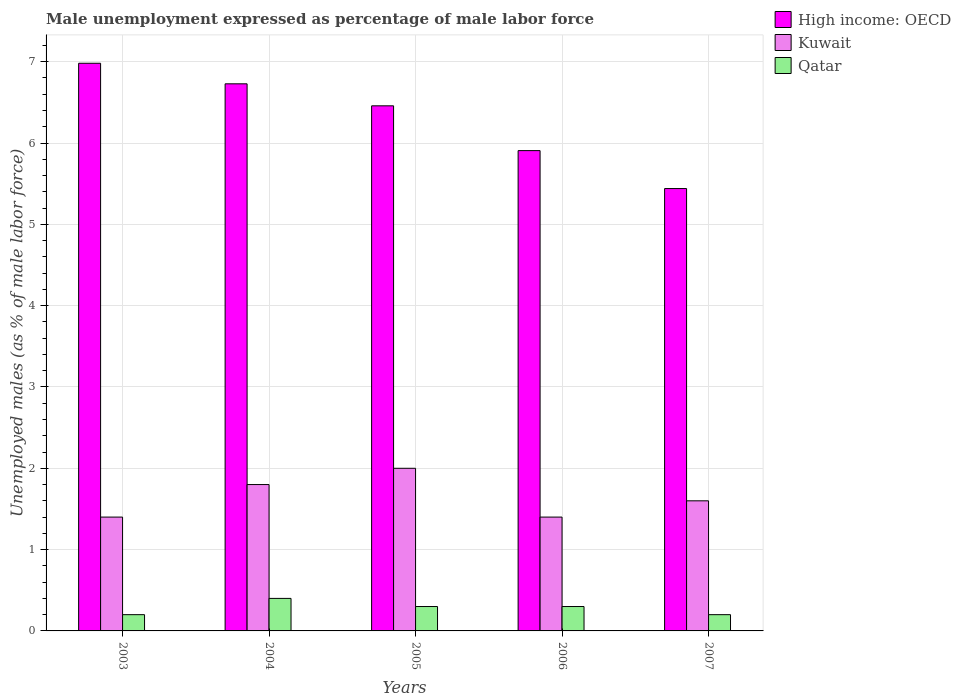How many groups of bars are there?
Offer a very short reply. 5. Are the number of bars on each tick of the X-axis equal?
Keep it short and to the point. Yes. How many bars are there on the 5th tick from the right?
Provide a succinct answer. 3. What is the label of the 1st group of bars from the left?
Keep it short and to the point. 2003. In how many cases, is the number of bars for a given year not equal to the number of legend labels?
Make the answer very short. 0. What is the unemployment in males in in Kuwait in 2007?
Make the answer very short. 1.6. Across all years, what is the maximum unemployment in males in in Kuwait?
Ensure brevity in your answer.  2. Across all years, what is the minimum unemployment in males in in High income: OECD?
Make the answer very short. 5.44. In which year was the unemployment in males in in Kuwait minimum?
Keep it short and to the point. 2003. What is the total unemployment in males in in Qatar in the graph?
Give a very brief answer. 1.4. What is the difference between the unemployment in males in in Qatar in 2003 and that in 2004?
Offer a terse response. -0.2. What is the difference between the unemployment in males in in Qatar in 2003 and the unemployment in males in in Kuwait in 2004?
Provide a short and direct response. -1.6. What is the average unemployment in males in in Kuwait per year?
Make the answer very short. 1.64. In the year 2004, what is the difference between the unemployment in males in in Kuwait and unemployment in males in in High income: OECD?
Offer a terse response. -4.93. What is the ratio of the unemployment in males in in High income: OECD in 2004 to that in 2005?
Provide a succinct answer. 1.04. Is the unemployment in males in in High income: OECD in 2004 less than that in 2005?
Your response must be concise. No. Is the difference between the unemployment in males in in Kuwait in 2003 and 2005 greater than the difference between the unemployment in males in in High income: OECD in 2003 and 2005?
Provide a short and direct response. No. What is the difference between the highest and the second highest unemployment in males in in Kuwait?
Ensure brevity in your answer.  0.2. What is the difference between the highest and the lowest unemployment in males in in Kuwait?
Offer a terse response. 0.6. In how many years, is the unemployment in males in in Qatar greater than the average unemployment in males in in Qatar taken over all years?
Give a very brief answer. 3. Is the sum of the unemployment in males in in Qatar in 2004 and 2005 greater than the maximum unemployment in males in in High income: OECD across all years?
Your answer should be compact. No. What does the 3rd bar from the left in 2004 represents?
Your response must be concise. Qatar. What does the 1st bar from the right in 2007 represents?
Give a very brief answer. Qatar. Are all the bars in the graph horizontal?
Offer a terse response. No. Does the graph contain any zero values?
Provide a succinct answer. No. How are the legend labels stacked?
Offer a very short reply. Vertical. What is the title of the graph?
Your answer should be very brief. Male unemployment expressed as percentage of male labor force. What is the label or title of the X-axis?
Keep it short and to the point. Years. What is the label or title of the Y-axis?
Ensure brevity in your answer.  Unemployed males (as % of male labor force). What is the Unemployed males (as % of male labor force) in High income: OECD in 2003?
Offer a very short reply. 6.98. What is the Unemployed males (as % of male labor force) in Kuwait in 2003?
Your answer should be very brief. 1.4. What is the Unemployed males (as % of male labor force) of Qatar in 2003?
Give a very brief answer. 0.2. What is the Unemployed males (as % of male labor force) of High income: OECD in 2004?
Your response must be concise. 6.73. What is the Unemployed males (as % of male labor force) of Kuwait in 2004?
Your answer should be compact. 1.8. What is the Unemployed males (as % of male labor force) of Qatar in 2004?
Ensure brevity in your answer.  0.4. What is the Unemployed males (as % of male labor force) in High income: OECD in 2005?
Provide a short and direct response. 6.46. What is the Unemployed males (as % of male labor force) of Qatar in 2005?
Ensure brevity in your answer.  0.3. What is the Unemployed males (as % of male labor force) in High income: OECD in 2006?
Offer a very short reply. 5.91. What is the Unemployed males (as % of male labor force) in Kuwait in 2006?
Ensure brevity in your answer.  1.4. What is the Unemployed males (as % of male labor force) of Qatar in 2006?
Your response must be concise. 0.3. What is the Unemployed males (as % of male labor force) of High income: OECD in 2007?
Offer a very short reply. 5.44. What is the Unemployed males (as % of male labor force) of Kuwait in 2007?
Make the answer very short. 1.6. What is the Unemployed males (as % of male labor force) in Qatar in 2007?
Your answer should be very brief. 0.2. Across all years, what is the maximum Unemployed males (as % of male labor force) in High income: OECD?
Your answer should be very brief. 6.98. Across all years, what is the maximum Unemployed males (as % of male labor force) in Kuwait?
Offer a terse response. 2. Across all years, what is the maximum Unemployed males (as % of male labor force) of Qatar?
Give a very brief answer. 0.4. Across all years, what is the minimum Unemployed males (as % of male labor force) in High income: OECD?
Your answer should be compact. 5.44. Across all years, what is the minimum Unemployed males (as % of male labor force) of Kuwait?
Offer a terse response. 1.4. Across all years, what is the minimum Unemployed males (as % of male labor force) in Qatar?
Provide a short and direct response. 0.2. What is the total Unemployed males (as % of male labor force) in High income: OECD in the graph?
Your answer should be compact. 31.51. What is the total Unemployed males (as % of male labor force) of Qatar in the graph?
Offer a very short reply. 1.4. What is the difference between the Unemployed males (as % of male labor force) of High income: OECD in 2003 and that in 2004?
Ensure brevity in your answer.  0.25. What is the difference between the Unemployed males (as % of male labor force) of Kuwait in 2003 and that in 2004?
Give a very brief answer. -0.4. What is the difference between the Unemployed males (as % of male labor force) in High income: OECD in 2003 and that in 2005?
Your answer should be very brief. 0.52. What is the difference between the Unemployed males (as % of male labor force) of High income: OECD in 2003 and that in 2006?
Make the answer very short. 1.07. What is the difference between the Unemployed males (as % of male labor force) in Kuwait in 2003 and that in 2006?
Your response must be concise. 0. What is the difference between the Unemployed males (as % of male labor force) of High income: OECD in 2003 and that in 2007?
Make the answer very short. 1.54. What is the difference between the Unemployed males (as % of male labor force) of Kuwait in 2003 and that in 2007?
Your response must be concise. -0.2. What is the difference between the Unemployed males (as % of male labor force) of Qatar in 2003 and that in 2007?
Offer a very short reply. 0. What is the difference between the Unemployed males (as % of male labor force) in High income: OECD in 2004 and that in 2005?
Offer a terse response. 0.27. What is the difference between the Unemployed males (as % of male labor force) of Kuwait in 2004 and that in 2005?
Your response must be concise. -0.2. What is the difference between the Unemployed males (as % of male labor force) of High income: OECD in 2004 and that in 2006?
Keep it short and to the point. 0.82. What is the difference between the Unemployed males (as % of male labor force) of Kuwait in 2004 and that in 2006?
Ensure brevity in your answer.  0.4. What is the difference between the Unemployed males (as % of male labor force) of Qatar in 2004 and that in 2006?
Ensure brevity in your answer.  0.1. What is the difference between the Unemployed males (as % of male labor force) of High income: OECD in 2004 and that in 2007?
Give a very brief answer. 1.29. What is the difference between the Unemployed males (as % of male labor force) in Kuwait in 2004 and that in 2007?
Your answer should be compact. 0.2. What is the difference between the Unemployed males (as % of male labor force) in High income: OECD in 2005 and that in 2006?
Keep it short and to the point. 0.55. What is the difference between the Unemployed males (as % of male labor force) in High income: OECD in 2005 and that in 2007?
Provide a succinct answer. 1.02. What is the difference between the Unemployed males (as % of male labor force) of Kuwait in 2005 and that in 2007?
Your answer should be compact. 0.4. What is the difference between the Unemployed males (as % of male labor force) of Qatar in 2005 and that in 2007?
Give a very brief answer. 0.1. What is the difference between the Unemployed males (as % of male labor force) of High income: OECD in 2006 and that in 2007?
Give a very brief answer. 0.47. What is the difference between the Unemployed males (as % of male labor force) of Qatar in 2006 and that in 2007?
Keep it short and to the point. 0.1. What is the difference between the Unemployed males (as % of male labor force) of High income: OECD in 2003 and the Unemployed males (as % of male labor force) of Kuwait in 2004?
Your answer should be very brief. 5.18. What is the difference between the Unemployed males (as % of male labor force) in High income: OECD in 2003 and the Unemployed males (as % of male labor force) in Qatar in 2004?
Provide a short and direct response. 6.58. What is the difference between the Unemployed males (as % of male labor force) of Kuwait in 2003 and the Unemployed males (as % of male labor force) of Qatar in 2004?
Your answer should be very brief. 1. What is the difference between the Unemployed males (as % of male labor force) in High income: OECD in 2003 and the Unemployed males (as % of male labor force) in Kuwait in 2005?
Provide a short and direct response. 4.98. What is the difference between the Unemployed males (as % of male labor force) of High income: OECD in 2003 and the Unemployed males (as % of male labor force) of Qatar in 2005?
Make the answer very short. 6.68. What is the difference between the Unemployed males (as % of male labor force) in Kuwait in 2003 and the Unemployed males (as % of male labor force) in Qatar in 2005?
Keep it short and to the point. 1.1. What is the difference between the Unemployed males (as % of male labor force) in High income: OECD in 2003 and the Unemployed males (as % of male labor force) in Kuwait in 2006?
Make the answer very short. 5.58. What is the difference between the Unemployed males (as % of male labor force) of High income: OECD in 2003 and the Unemployed males (as % of male labor force) of Qatar in 2006?
Make the answer very short. 6.68. What is the difference between the Unemployed males (as % of male labor force) in High income: OECD in 2003 and the Unemployed males (as % of male labor force) in Kuwait in 2007?
Your answer should be very brief. 5.38. What is the difference between the Unemployed males (as % of male labor force) in High income: OECD in 2003 and the Unemployed males (as % of male labor force) in Qatar in 2007?
Your answer should be compact. 6.78. What is the difference between the Unemployed males (as % of male labor force) in High income: OECD in 2004 and the Unemployed males (as % of male labor force) in Kuwait in 2005?
Provide a short and direct response. 4.73. What is the difference between the Unemployed males (as % of male labor force) of High income: OECD in 2004 and the Unemployed males (as % of male labor force) of Qatar in 2005?
Provide a succinct answer. 6.43. What is the difference between the Unemployed males (as % of male labor force) of Kuwait in 2004 and the Unemployed males (as % of male labor force) of Qatar in 2005?
Keep it short and to the point. 1.5. What is the difference between the Unemployed males (as % of male labor force) in High income: OECD in 2004 and the Unemployed males (as % of male labor force) in Kuwait in 2006?
Make the answer very short. 5.33. What is the difference between the Unemployed males (as % of male labor force) in High income: OECD in 2004 and the Unemployed males (as % of male labor force) in Qatar in 2006?
Your response must be concise. 6.43. What is the difference between the Unemployed males (as % of male labor force) of High income: OECD in 2004 and the Unemployed males (as % of male labor force) of Kuwait in 2007?
Give a very brief answer. 5.13. What is the difference between the Unemployed males (as % of male labor force) in High income: OECD in 2004 and the Unemployed males (as % of male labor force) in Qatar in 2007?
Keep it short and to the point. 6.53. What is the difference between the Unemployed males (as % of male labor force) of Kuwait in 2004 and the Unemployed males (as % of male labor force) of Qatar in 2007?
Your answer should be compact. 1.6. What is the difference between the Unemployed males (as % of male labor force) in High income: OECD in 2005 and the Unemployed males (as % of male labor force) in Kuwait in 2006?
Give a very brief answer. 5.06. What is the difference between the Unemployed males (as % of male labor force) of High income: OECD in 2005 and the Unemployed males (as % of male labor force) of Qatar in 2006?
Make the answer very short. 6.16. What is the difference between the Unemployed males (as % of male labor force) in Kuwait in 2005 and the Unemployed males (as % of male labor force) in Qatar in 2006?
Your answer should be compact. 1.7. What is the difference between the Unemployed males (as % of male labor force) of High income: OECD in 2005 and the Unemployed males (as % of male labor force) of Kuwait in 2007?
Make the answer very short. 4.86. What is the difference between the Unemployed males (as % of male labor force) in High income: OECD in 2005 and the Unemployed males (as % of male labor force) in Qatar in 2007?
Ensure brevity in your answer.  6.26. What is the difference between the Unemployed males (as % of male labor force) of Kuwait in 2005 and the Unemployed males (as % of male labor force) of Qatar in 2007?
Ensure brevity in your answer.  1.8. What is the difference between the Unemployed males (as % of male labor force) in High income: OECD in 2006 and the Unemployed males (as % of male labor force) in Kuwait in 2007?
Give a very brief answer. 4.31. What is the difference between the Unemployed males (as % of male labor force) of High income: OECD in 2006 and the Unemployed males (as % of male labor force) of Qatar in 2007?
Make the answer very short. 5.71. What is the average Unemployed males (as % of male labor force) in High income: OECD per year?
Give a very brief answer. 6.3. What is the average Unemployed males (as % of male labor force) in Kuwait per year?
Make the answer very short. 1.64. What is the average Unemployed males (as % of male labor force) in Qatar per year?
Ensure brevity in your answer.  0.28. In the year 2003, what is the difference between the Unemployed males (as % of male labor force) of High income: OECD and Unemployed males (as % of male labor force) of Kuwait?
Keep it short and to the point. 5.58. In the year 2003, what is the difference between the Unemployed males (as % of male labor force) of High income: OECD and Unemployed males (as % of male labor force) of Qatar?
Make the answer very short. 6.78. In the year 2003, what is the difference between the Unemployed males (as % of male labor force) in Kuwait and Unemployed males (as % of male labor force) in Qatar?
Ensure brevity in your answer.  1.2. In the year 2004, what is the difference between the Unemployed males (as % of male labor force) of High income: OECD and Unemployed males (as % of male labor force) of Kuwait?
Your answer should be very brief. 4.93. In the year 2004, what is the difference between the Unemployed males (as % of male labor force) of High income: OECD and Unemployed males (as % of male labor force) of Qatar?
Your response must be concise. 6.33. In the year 2004, what is the difference between the Unemployed males (as % of male labor force) in Kuwait and Unemployed males (as % of male labor force) in Qatar?
Provide a succinct answer. 1.4. In the year 2005, what is the difference between the Unemployed males (as % of male labor force) of High income: OECD and Unemployed males (as % of male labor force) of Kuwait?
Ensure brevity in your answer.  4.46. In the year 2005, what is the difference between the Unemployed males (as % of male labor force) of High income: OECD and Unemployed males (as % of male labor force) of Qatar?
Provide a short and direct response. 6.16. In the year 2005, what is the difference between the Unemployed males (as % of male labor force) of Kuwait and Unemployed males (as % of male labor force) of Qatar?
Ensure brevity in your answer.  1.7. In the year 2006, what is the difference between the Unemployed males (as % of male labor force) in High income: OECD and Unemployed males (as % of male labor force) in Kuwait?
Give a very brief answer. 4.51. In the year 2006, what is the difference between the Unemployed males (as % of male labor force) of High income: OECD and Unemployed males (as % of male labor force) of Qatar?
Make the answer very short. 5.61. In the year 2006, what is the difference between the Unemployed males (as % of male labor force) in Kuwait and Unemployed males (as % of male labor force) in Qatar?
Your answer should be very brief. 1.1. In the year 2007, what is the difference between the Unemployed males (as % of male labor force) of High income: OECD and Unemployed males (as % of male labor force) of Kuwait?
Make the answer very short. 3.84. In the year 2007, what is the difference between the Unemployed males (as % of male labor force) in High income: OECD and Unemployed males (as % of male labor force) in Qatar?
Offer a very short reply. 5.24. In the year 2007, what is the difference between the Unemployed males (as % of male labor force) of Kuwait and Unemployed males (as % of male labor force) of Qatar?
Keep it short and to the point. 1.4. What is the ratio of the Unemployed males (as % of male labor force) in High income: OECD in 2003 to that in 2004?
Offer a very short reply. 1.04. What is the ratio of the Unemployed males (as % of male labor force) of High income: OECD in 2003 to that in 2005?
Provide a short and direct response. 1.08. What is the ratio of the Unemployed males (as % of male labor force) of High income: OECD in 2003 to that in 2006?
Ensure brevity in your answer.  1.18. What is the ratio of the Unemployed males (as % of male labor force) in Qatar in 2003 to that in 2006?
Give a very brief answer. 0.67. What is the ratio of the Unemployed males (as % of male labor force) in High income: OECD in 2003 to that in 2007?
Provide a succinct answer. 1.28. What is the ratio of the Unemployed males (as % of male labor force) of Kuwait in 2003 to that in 2007?
Give a very brief answer. 0.88. What is the ratio of the Unemployed males (as % of male labor force) of High income: OECD in 2004 to that in 2005?
Your response must be concise. 1.04. What is the ratio of the Unemployed males (as % of male labor force) in Kuwait in 2004 to that in 2005?
Provide a succinct answer. 0.9. What is the ratio of the Unemployed males (as % of male labor force) in High income: OECD in 2004 to that in 2006?
Ensure brevity in your answer.  1.14. What is the ratio of the Unemployed males (as % of male labor force) of High income: OECD in 2004 to that in 2007?
Ensure brevity in your answer.  1.24. What is the ratio of the Unemployed males (as % of male labor force) in Kuwait in 2004 to that in 2007?
Keep it short and to the point. 1.12. What is the ratio of the Unemployed males (as % of male labor force) of Qatar in 2004 to that in 2007?
Give a very brief answer. 2. What is the ratio of the Unemployed males (as % of male labor force) of High income: OECD in 2005 to that in 2006?
Your answer should be very brief. 1.09. What is the ratio of the Unemployed males (as % of male labor force) of Kuwait in 2005 to that in 2006?
Provide a succinct answer. 1.43. What is the ratio of the Unemployed males (as % of male labor force) in Qatar in 2005 to that in 2006?
Provide a short and direct response. 1. What is the ratio of the Unemployed males (as % of male labor force) of High income: OECD in 2005 to that in 2007?
Give a very brief answer. 1.19. What is the ratio of the Unemployed males (as % of male labor force) of Qatar in 2005 to that in 2007?
Provide a succinct answer. 1.5. What is the ratio of the Unemployed males (as % of male labor force) of High income: OECD in 2006 to that in 2007?
Provide a short and direct response. 1.09. What is the ratio of the Unemployed males (as % of male labor force) in Kuwait in 2006 to that in 2007?
Make the answer very short. 0.88. What is the difference between the highest and the second highest Unemployed males (as % of male labor force) of High income: OECD?
Keep it short and to the point. 0.25. What is the difference between the highest and the second highest Unemployed males (as % of male labor force) of Kuwait?
Keep it short and to the point. 0.2. What is the difference between the highest and the lowest Unemployed males (as % of male labor force) of High income: OECD?
Provide a short and direct response. 1.54. 